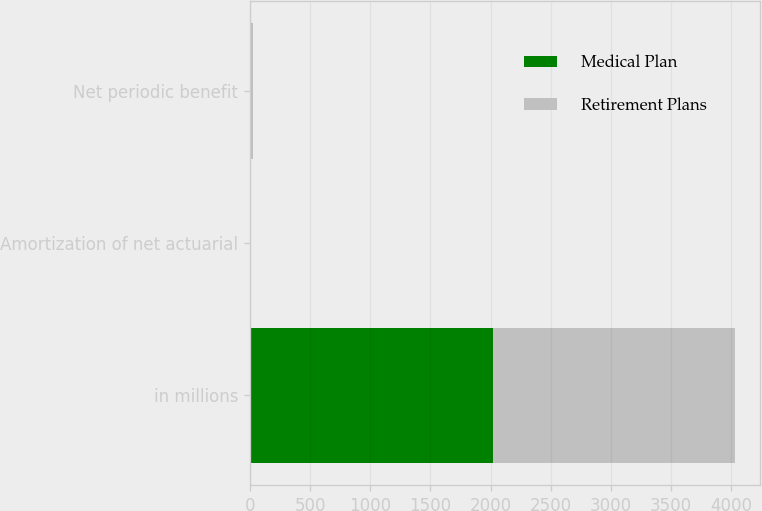<chart> <loc_0><loc_0><loc_500><loc_500><stacked_bar_chart><ecel><fcel>in millions<fcel>Amortization of net actuarial<fcel>Net periodic benefit<nl><fcel>Medical Plan<fcel>2017<fcel>3<fcel>4.3<nl><fcel>Retirement Plans<fcel>2016<fcel>0.3<fcel>20.6<nl></chart> 